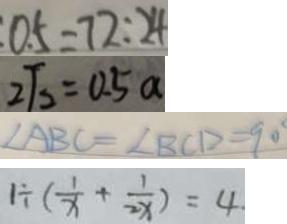<formula> <loc_0><loc_0><loc_500><loc_500>0 . 5 = 7 2 : 2 4 
 2 \sqrt { 2 } = 0 . 5 a 
 \angle A B C = \angle B C D = 9 0 ^ { \circ } 
 1 \div ( \frac { 1 } { x } + \frac { 1 } { 2 x } ) = 4</formula> 